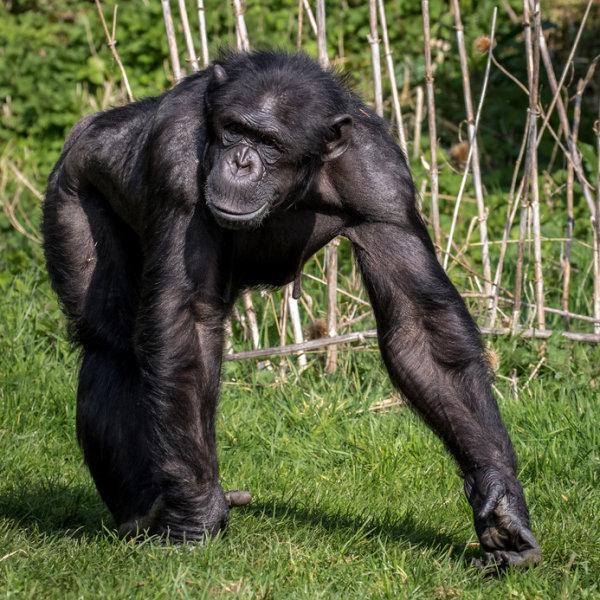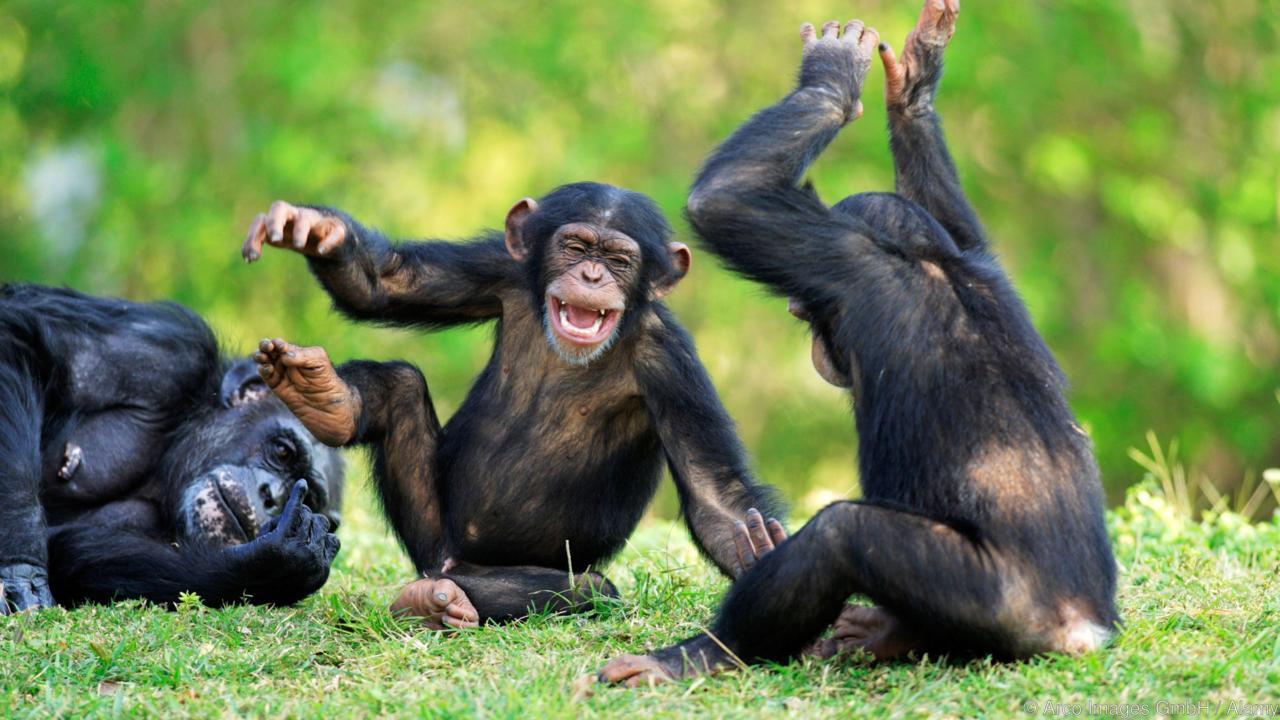The first image is the image on the left, the second image is the image on the right. For the images displayed, is the sentence "An image shows one or more young chimps with hand raised at least at head level." factually correct? Answer yes or no. Yes. 